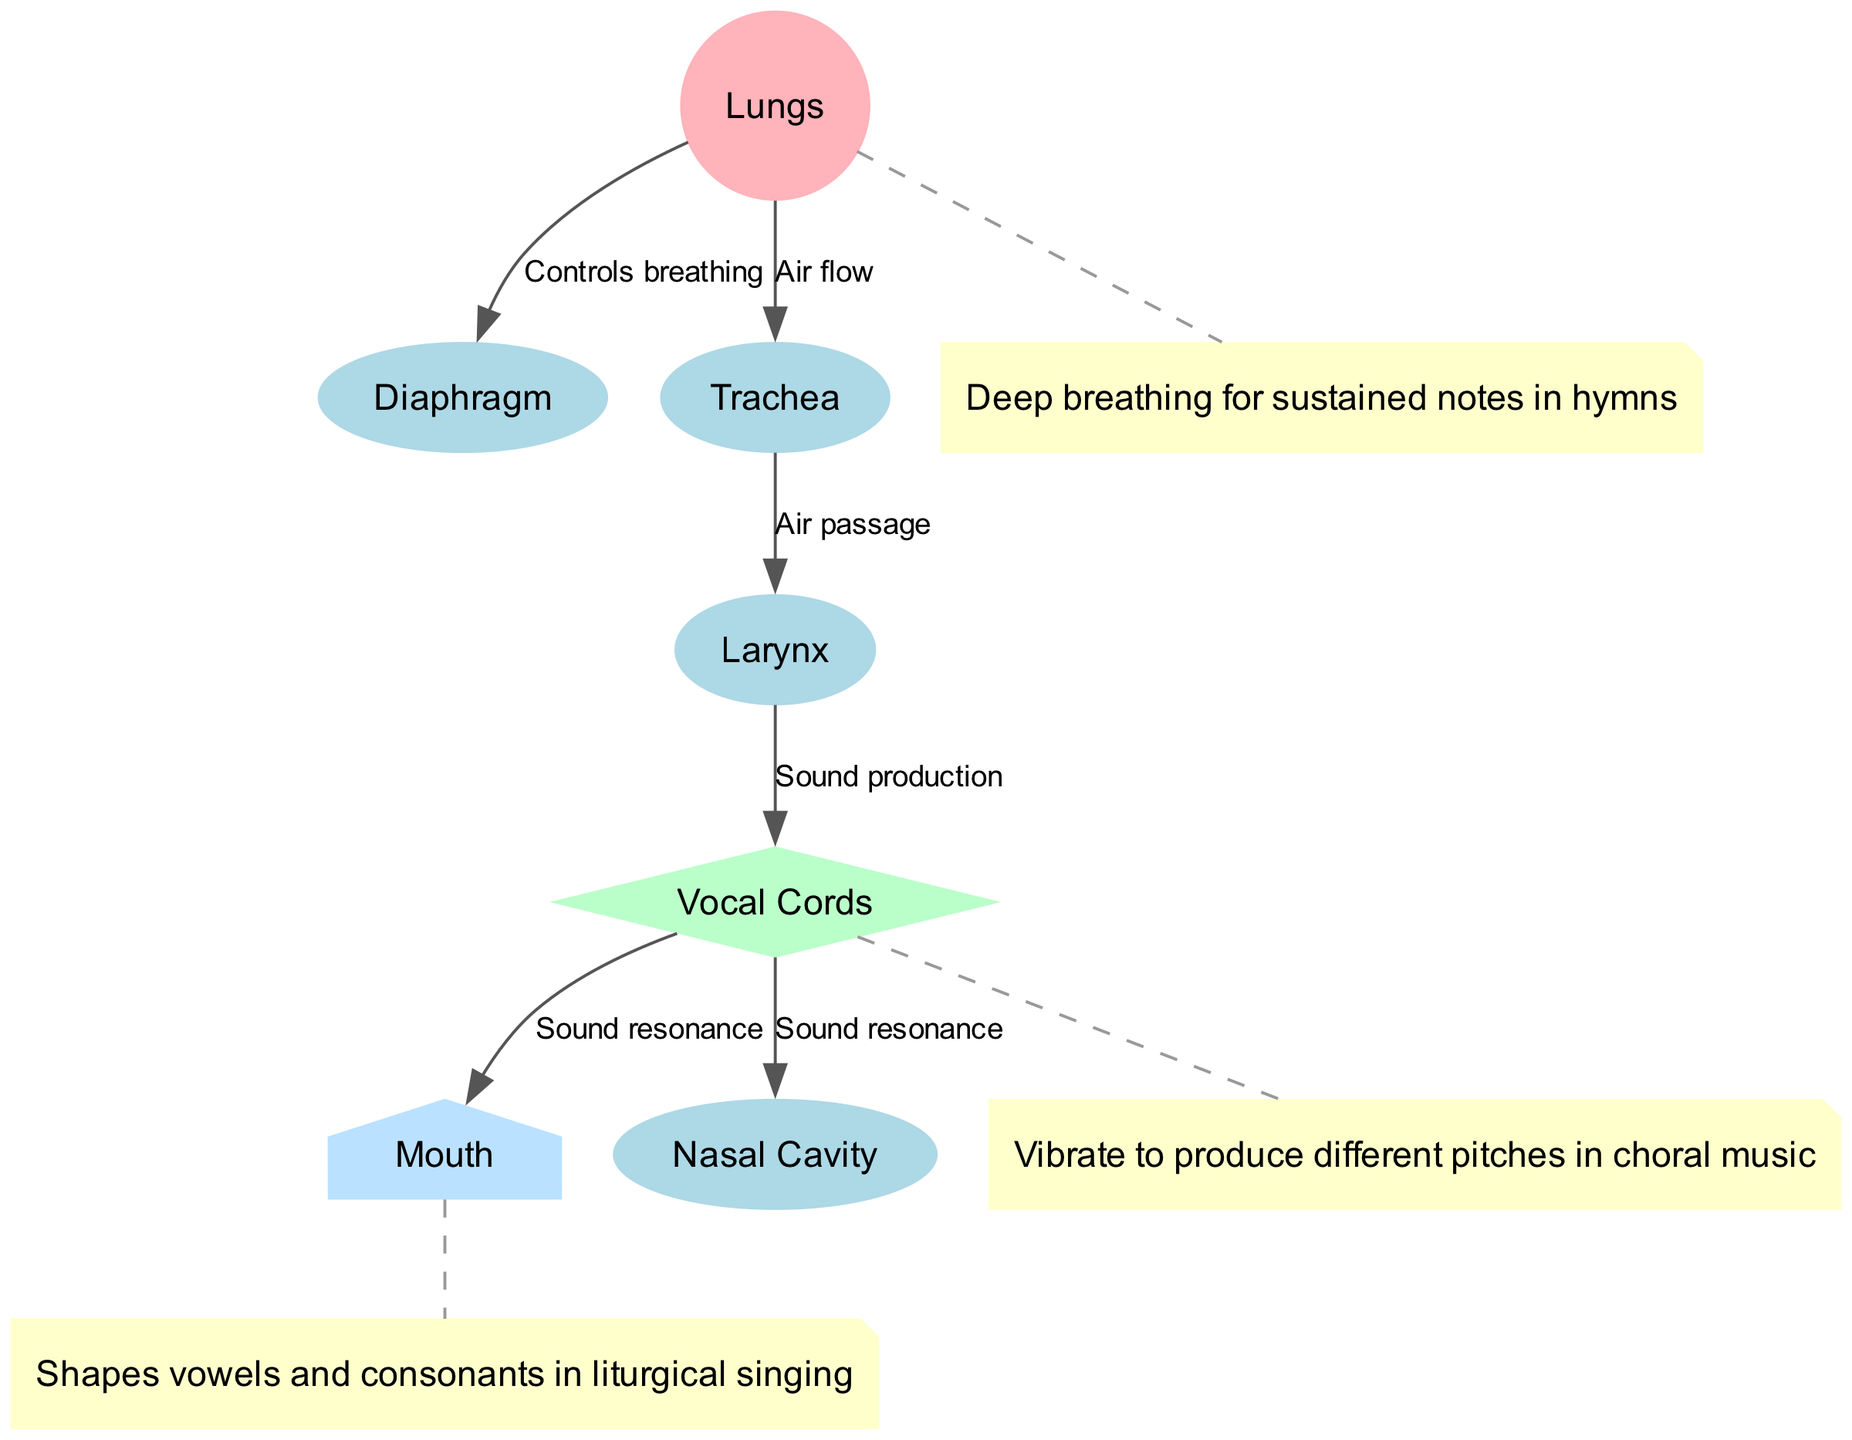What is the primary function of the lungs in the diagram? The diagram indicates that the lungs are responsible for controlling breathing, as shown by the edge labeled "Controls breathing."
Answer: Controls breathing How many nodes are present in the diagram? By counting the listed nodes, there are a total of seven: lungs, diaphragm, vocal cords, larynx, trachea, mouth, and nasal cavity.
Answer: Seven Which node is involved in sound production? The edge in the diagram indicates that the larynx connects to the vocal cords with the label "Sound production," meaning the vocal cords are directly responsible for producing sound.
Answer: Vocal Cords What connects the trachea to the larynx? The diagram specifies an edge labeled "Air passage" that indicates the direct connection from the trachea to the larynx.
Answer: Air passage How do vocal cords change the pitch of sound? The annotation states that the vocal cords vibrate to produce different pitches, which is supported by their function connection in the diagram leading to sound production.
Answer: Vibrate What is the role of the diaphragm in singing? The diagram outlines that the diaphragm, which is connected to the lungs, controls breathing and is crucial for deep breaths that sustain notes during singing.
Answer: Controls breathing How does sound resonance occur according to the diagram? The diagram shows two paths from the vocal cords to the mouth and the nasal cavity, both labeled "Sound resonance," indicating that these areas contribute to the resonance of sound produced by the vocal cords.
Answer: Mouth and Nasal Cavity What is the connection labeled between vocal cords and mouth? The diagram explicitly shows an edge from the vocal cords to the mouth, labeled "Sound resonance," illustrating the relationship between these two features in sound production.
Answer: Sound resonance What does the annotation associated with the lungs describe? The annotation next to the lungs defines "Deep breathing for sustained notes in hymns," which describes their significance in choral singing.
Answer: Deep breathing for sustained notes in hymns 